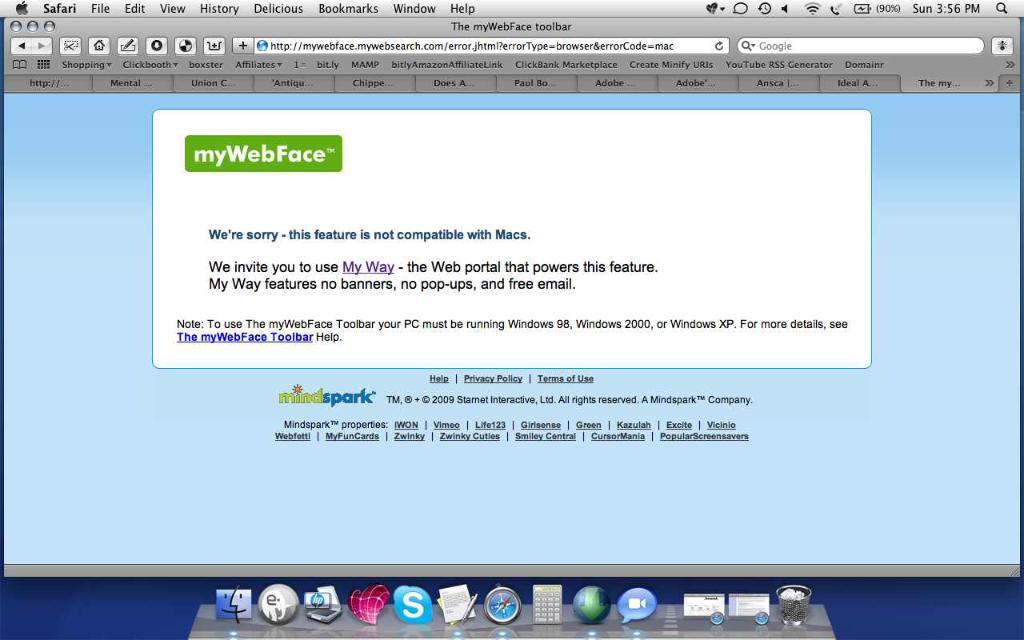Provide a one-sentence caption for the provided image. An error page that states the feature is not compatible. 